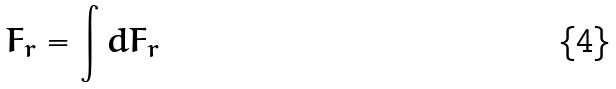Convert formula to latex. <formula><loc_0><loc_0><loc_500><loc_500>F _ { r } = \int d F _ { r }</formula> 